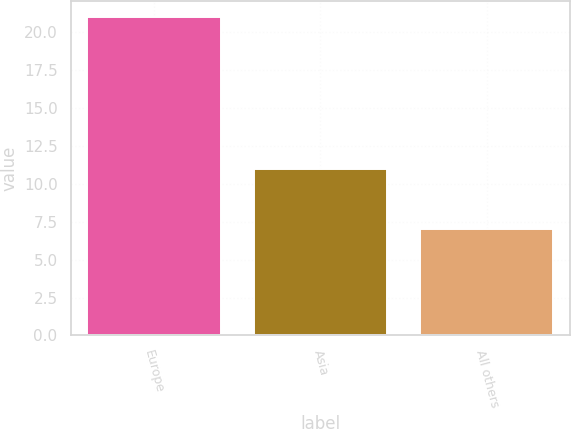Convert chart to OTSL. <chart><loc_0><loc_0><loc_500><loc_500><bar_chart><fcel>Europe<fcel>Asia<fcel>All others<nl><fcel>21<fcel>11<fcel>7<nl></chart> 